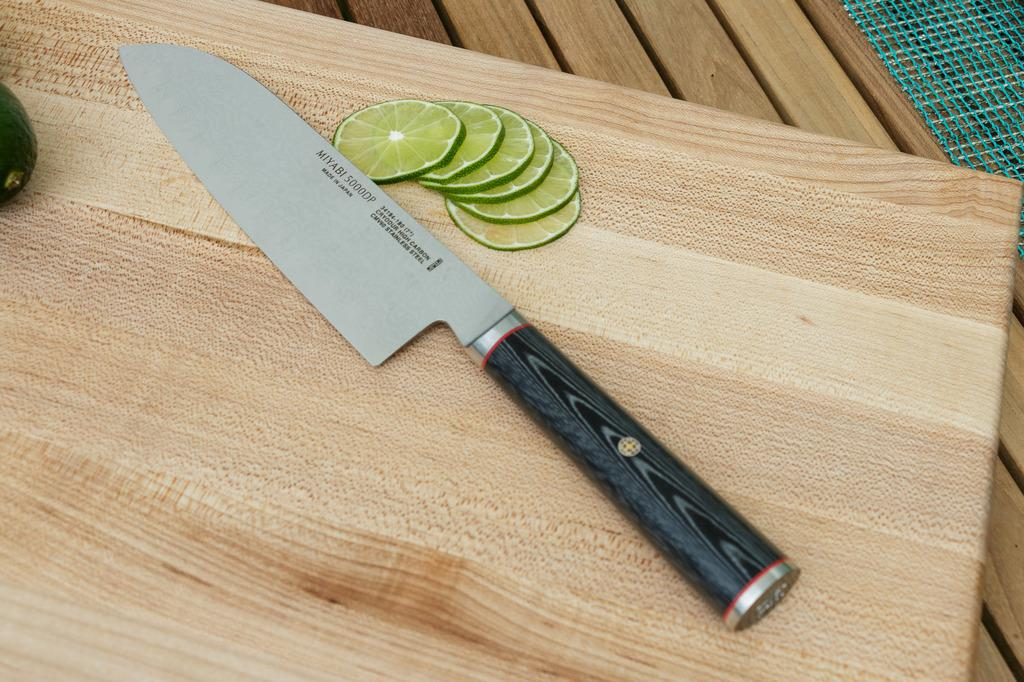What piece of furniture is present in the image? There is a table in the image. What is placed on the table? There is a mat, a chopping board, a knife, lemon slices, and a vegetable on the table. What is the purpose of the chopping board? The chopping board is likely used for cutting or preparing food. What type of vegetable is on the table? The specific type of vegetable is not mentioned, but it is present on the table. What color is the bed in the image? There is no bed present in the image; it features a table with various items on it. 